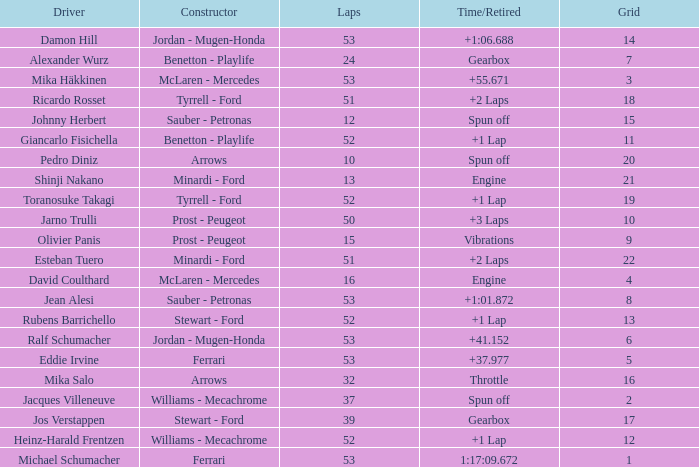What is the high lap total for pedro diniz? 10.0. 